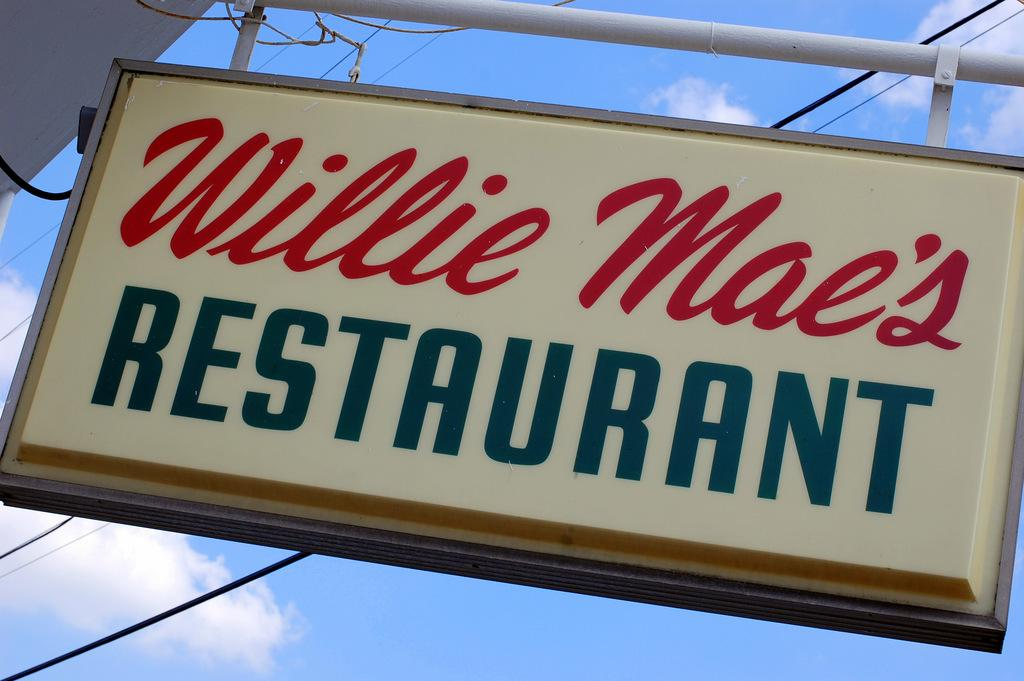<image>
Offer a succinct explanation of the picture presented. Willie Mae's Restaurant has a red and navy blue sign. 